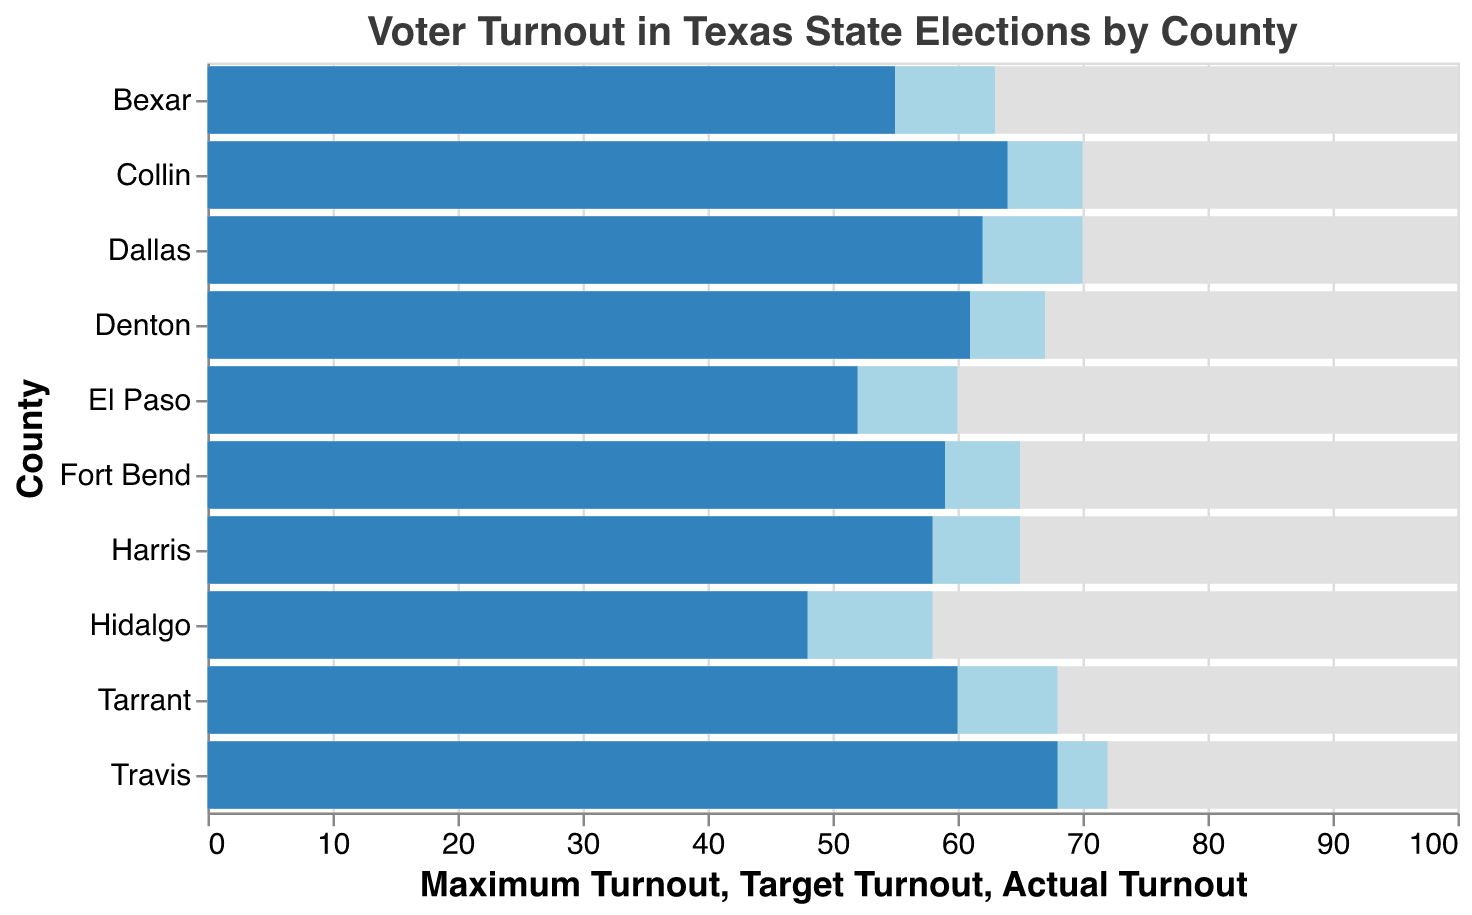What's the actual voter turnout in Tarrant County? The bar representing Tarrant County's actual turnout is labeled with a value of 60.
Answer: 60 Which county has the highest actual voter turnout? The actual turnout bar for Travis County reaches the highest point at 68.
Answer: Travis How much higher is the target turnout in Dallas County compared to the actual turnout? The target turnout for Dallas is 70, and the actual turnout is 62. The difference is 70 - 62.
Answer: 8 What is the range of target turnouts across all counties? The lowest target turnout is 58 (Hidalgo) and the highest is 72 (Travis). The range is 72 - 58.
Answer: 14 How many counties have an actual turnout greater than 60? Checking the bars for actual turnout, Dallas (62), Tarrant (60), Travis (68), Collin (64), and Denton (61) all have actual turnout values greater than or equal to 60.
Answer: 5 Which county has the largest gap between its actual turnout and maximum turnout? The largest gap happens when the actual turnout is the lowest, which is in Hidalgo with a turnout of 48 against 100. The gap is 100 - 48.
Answer: 52 By how much does Bexar County's actual turnout fall short of its target? Bexar County's actual turnout is 55 and its target is 63. The difference is 63 - 55.
Answer: 8 Which counties have actual turnout higher than their target turnout? From the chart, no actual turnout bars surpass their corresponding target turnout bar.
Answer: None What is the average actual turnout across all counties? Sum of actual turnouts: 58+62+60+55+68+64+61+52+59+48 = 587. There are 10 counties, so the average is 587 / 10.
Answer: 58.7 What proportion of counties have a target turnout of 65 or higher? The counties with targets of 65 or higher are Harris (65), Dallas (70), Tarrant (68), Travis (72), Collin (70), Denton (67), and Fort Bend (65). That makes 7 out of 10 counties, which is 7/10.
Answer: 0.7 